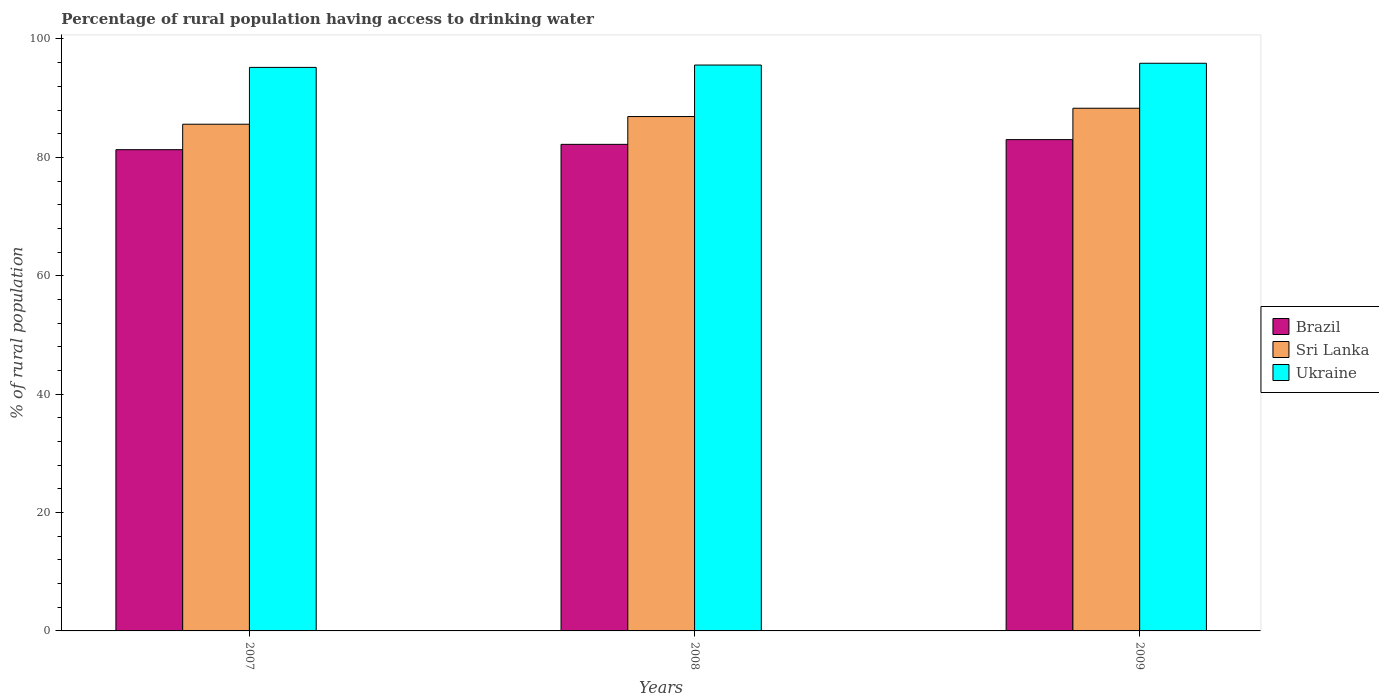How many different coloured bars are there?
Offer a very short reply. 3. Are the number of bars per tick equal to the number of legend labels?
Make the answer very short. Yes. What is the label of the 2nd group of bars from the left?
Offer a very short reply. 2008. What is the percentage of rural population having access to drinking water in Ukraine in 2008?
Provide a succinct answer. 95.6. Across all years, what is the maximum percentage of rural population having access to drinking water in Ukraine?
Provide a succinct answer. 95.9. Across all years, what is the minimum percentage of rural population having access to drinking water in Sri Lanka?
Your answer should be very brief. 85.6. What is the total percentage of rural population having access to drinking water in Sri Lanka in the graph?
Give a very brief answer. 260.8. What is the difference between the percentage of rural population having access to drinking water in Sri Lanka in 2007 and that in 2009?
Offer a very short reply. -2.7. What is the difference between the percentage of rural population having access to drinking water in Ukraine in 2008 and the percentage of rural population having access to drinking water in Sri Lanka in 2009?
Provide a short and direct response. 7.3. What is the average percentage of rural population having access to drinking water in Sri Lanka per year?
Provide a short and direct response. 86.93. In the year 2008, what is the difference between the percentage of rural population having access to drinking water in Sri Lanka and percentage of rural population having access to drinking water in Brazil?
Ensure brevity in your answer.  4.7. What is the ratio of the percentage of rural population having access to drinking water in Brazil in 2007 to that in 2008?
Your response must be concise. 0.99. Is the percentage of rural population having access to drinking water in Ukraine in 2007 less than that in 2008?
Provide a succinct answer. Yes. Is the difference between the percentage of rural population having access to drinking water in Sri Lanka in 2007 and 2008 greater than the difference between the percentage of rural population having access to drinking water in Brazil in 2007 and 2008?
Give a very brief answer. No. What is the difference between the highest and the second highest percentage of rural population having access to drinking water in Brazil?
Your answer should be compact. 0.8. What is the difference between the highest and the lowest percentage of rural population having access to drinking water in Sri Lanka?
Provide a succinct answer. 2.7. Is the sum of the percentage of rural population having access to drinking water in Ukraine in 2008 and 2009 greater than the maximum percentage of rural population having access to drinking water in Sri Lanka across all years?
Provide a succinct answer. Yes. What does the 3rd bar from the left in 2009 represents?
Your answer should be compact. Ukraine. What does the 1st bar from the right in 2007 represents?
Keep it short and to the point. Ukraine. Is it the case that in every year, the sum of the percentage of rural population having access to drinking water in Sri Lanka and percentage of rural population having access to drinking water in Ukraine is greater than the percentage of rural population having access to drinking water in Brazil?
Provide a succinct answer. Yes. How many bars are there?
Your response must be concise. 9. Are all the bars in the graph horizontal?
Your answer should be very brief. No. Does the graph contain any zero values?
Make the answer very short. No. How are the legend labels stacked?
Your answer should be compact. Vertical. What is the title of the graph?
Offer a terse response. Percentage of rural population having access to drinking water. What is the label or title of the X-axis?
Offer a terse response. Years. What is the label or title of the Y-axis?
Keep it short and to the point. % of rural population. What is the % of rural population of Brazil in 2007?
Offer a very short reply. 81.3. What is the % of rural population of Sri Lanka in 2007?
Offer a terse response. 85.6. What is the % of rural population of Ukraine in 2007?
Provide a succinct answer. 95.2. What is the % of rural population of Brazil in 2008?
Keep it short and to the point. 82.2. What is the % of rural population of Sri Lanka in 2008?
Your response must be concise. 86.9. What is the % of rural population of Ukraine in 2008?
Provide a short and direct response. 95.6. What is the % of rural population in Brazil in 2009?
Provide a short and direct response. 83. What is the % of rural population in Sri Lanka in 2009?
Keep it short and to the point. 88.3. What is the % of rural population of Ukraine in 2009?
Provide a short and direct response. 95.9. Across all years, what is the maximum % of rural population in Brazil?
Offer a very short reply. 83. Across all years, what is the maximum % of rural population in Sri Lanka?
Your answer should be very brief. 88.3. Across all years, what is the maximum % of rural population in Ukraine?
Your answer should be very brief. 95.9. Across all years, what is the minimum % of rural population in Brazil?
Your answer should be very brief. 81.3. Across all years, what is the minimum % of rural population in Sri Lanka?
Ensure brevity in your answer.  85.6. Across all years, what is the minimum % of rural population of Ukraine?
Ensure brevity in your answer.  95.2. What is the total % of rural population in Brazil in the graph?
Offer a very short reply. 246.5. What is the total % of rural population in Sri Lanka in the graph?
Your answer should be compact. 260.8. What is the total % of rural population of Ukraine in the graph?
Offer a terse response. 286.7. What is the difference between the % of rural population of Ukraine in 2007 and that in 2008?
Ensure brevity in your answer.  -0.4. What is the difference between the % of rural population of Brazil in 2007 and that in 2009?
Make the answer very short. -1.7. What is the difference between the % of rural population of Ukraine in 2008 and that in 2009?
Give a very brief answer. -0.3. What is the difference between the % of rural population of Brazil in 2007 and the % of rural population of Ukraine in 2008?
Your answer should be very brief. -14.3. What is the difference between the % of rural population in Sri Lanka in 2007 and the % of rural population in Ukraine in 2008?
Your response must be concise. -10. What is the difference between the % of rural population in Brazil in 2007 and the % of rural population in Sri Lanka in 2009?
Provide a succinct answer. -7. What is the difference between the % of rural population of Brazil in 2007 and the % of rural population of Ukraine in 2009?
Keep it short and to the point. -14.6. What is the difference between the % of rural population of Sri Lanka in 2007 and the % of rural population of Ukraine in 2009?
Provide a succinct answer. -10.3. What is the difference between the % of rural population of Brazil in 2008 and the % of rural population of Ukraine in 2009?
Ensure brevity in your answer.  -13.7. What is the difference between the % of rural population in Sri Lanka in 2008 and the % of rural population in Ukraine in 2009?
Provide a succinct answer. -9. What is the average % of rural population in Brazil per year?
Your answer should be compact. 82.17. What is the average % of rural population of Sri Lanka per year?
Your answer should be compact. 86.93. What is the average % of rural population of Ukraine per year?
Offer a very short reply. 95.57. In the year 2007, what is the difference between the % of rural population in Brazil and % of rural population in Sri Lanka?
Provide a succinct answer. -4.3. In the year 2007, what is the difference between the % of rural population of Brazil and % of rural population of Ukraine?
Make the answer very short. -13.9. In the year 2008, what is the difference between the % of rural population of Brazil and % of rural population of Ukraine?
Your response must be concise. -13.4. In the year 2008, what is the difference between the % of rural population of Sri Lanka and % of rural population of Ukraine?
Provide a succinct answer. -8.7. In the year 2009, what is the difference between the % of rural population of Sri Lanka and % of rural population of Ukraine?
Offer a terse response. -7.6. What is the ratio of the % of rural population in Brazil in 2007 to that in 2008?
Your response must be concise. 0.99. What is the ratio of the % of rural population in Ukraine in 2007 to that in 2008?
Give a very brief answer. 1. What is the ratio of the % of rural population of Brazil in 2007 to that in 2009?
Offer a terse response. 0.98. What is the ratio of the % of rural population of Sri Lanka in 2007 to that in 2009?
Your answer should be very brief. 0.97. What is the ratio of the % of rural population of Ukraine in 2007 to that in 2009?
Ensure brevity in your answer.  0.99. What is the ratio of the % of rural population in Brazil in 2008 to that in 2009?
Your response must be concise. 0.99. What is the ratio of the % of rural population of Sri Lanka in 2008 to that in 2009?
Give a very brief answer. 0.98. What is the ratio of the % of rural population in Ukraine in 2008 to that in 2009?
Make the answer very short. 1. What is the difference between the highest and the second highest % of rural population in Brazil?
Your answer should be compact. 0.8. What is the difference between the highest and the second highest % of rural population of Sri Lanka?
Make the answer very short. 1.4. What is the difference between the highest and the lowest % of rural population of Ukraine?
Provide a short and direct response. 0.7. 